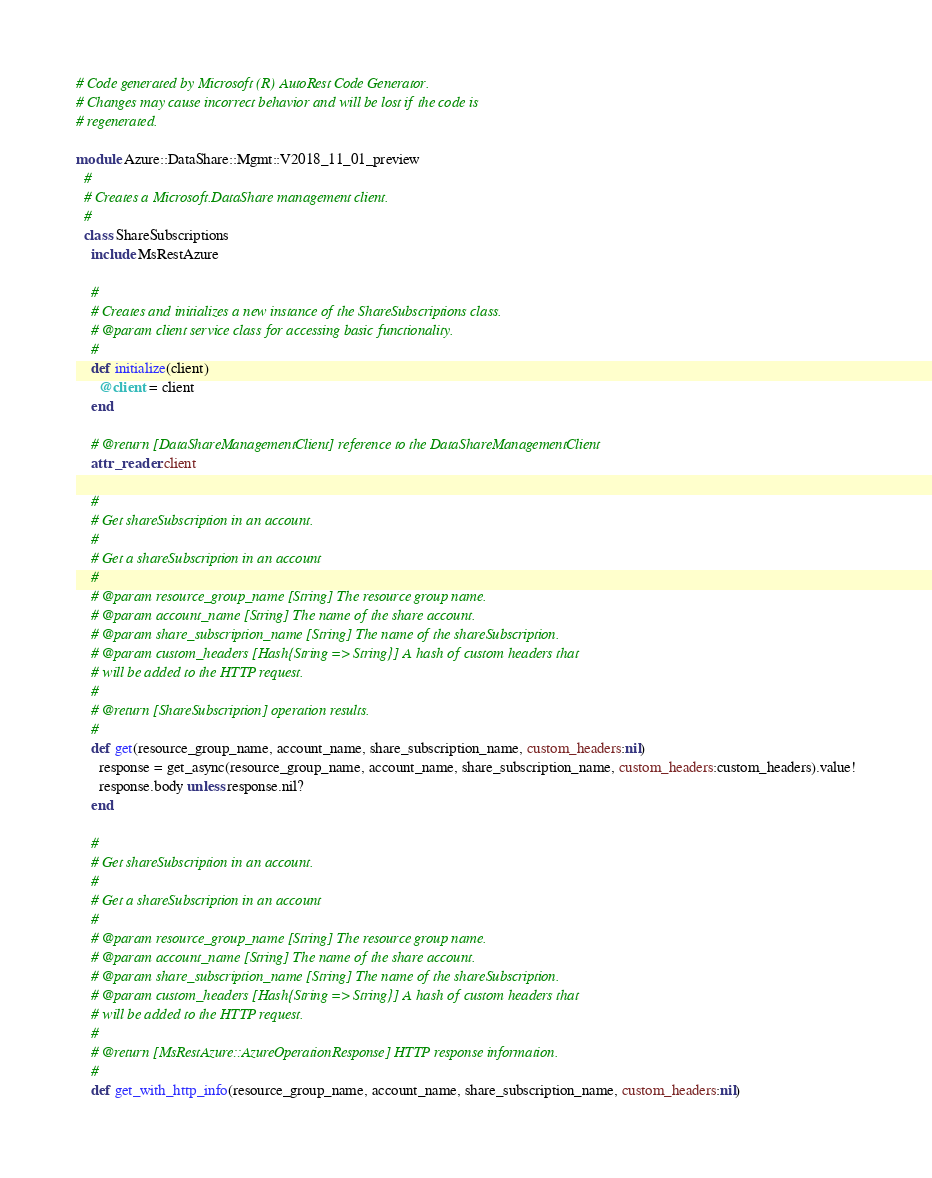Convert code to text. <code><loc_0><loc_0><loc_500><loc_500><_Ruby_># Code generated by Microsoft (R) AutoRest Code Generator.
# Changes may cause incorrect behavior and will be lost if the code is
# regenerated.

module Azure::DataShare::Mgmt::V2018_11_01_preview
  #
  # Creates a Microsoft.DataShare management client.
  #
  class ShareSubscriptions
    include MsRestAzure

    #
    # Creates and initializes a new instance of the ShareSubscriptions class.
    # @param client service class for accessing basic functionality.
    #
    def initialize(client)
      @client = client
    end

    # @return [DataShareManagementClient] reference to the DataShareManagementClient
    attr_reader :client

    #
    # Get shareSubscription in an account.
    #
    # Get a shareSubscription in an account
    #
    # @param resource_group_name [String] The resource group name.
    # @param account_name [String] The name of the share account.
    # @param share_subscription_name [String] The name of the shareSubscription.
    # @param custom_headers [Hash{String => String}] A hash of custom headers that
    # will be added to the HTTP request.
    #
    # @return [ShareSubscription] operation results.
    #
    def get(resource_group_name, account_name, share_subscription_name, custom_headers:nil)
      response = get_async(resource_group_name, account_name, share_subscription_name, custom_headers:custom_headers).value!
      response.body unless response.nil?
    end

    #
    # Get shareSubscription in an account.
    #
    # Get a shareSubscription in an account
    #
    # @param resource_group_name [String] The resource group name.
    # @param account_name [String] The name of the share account.
    # @param share_subscription_name [String] The name of the shareSubscription.
    # @param custom_headers [Hash{String => String}] A hash of custom headers that
    # will be added to the HTTP request.
    #
    # @return [MsRestAzure::AzureOperationResponse] HTTP response information.
    #
    def get_with_http_info(resource_group_name, account_name, share_subscription_name, custom_headers:nil)</code> 